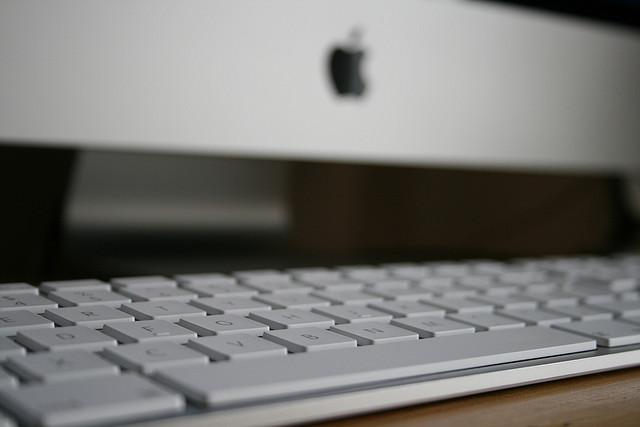What is this a photo of?
Concise answer only. Keyboard. What color is the keyboard?
Keep it brief. White. Is Bill Gates likely to buy this computer?
Keep it brief. No. What logo is above the keyboard?
Answer briefly. Apple. 